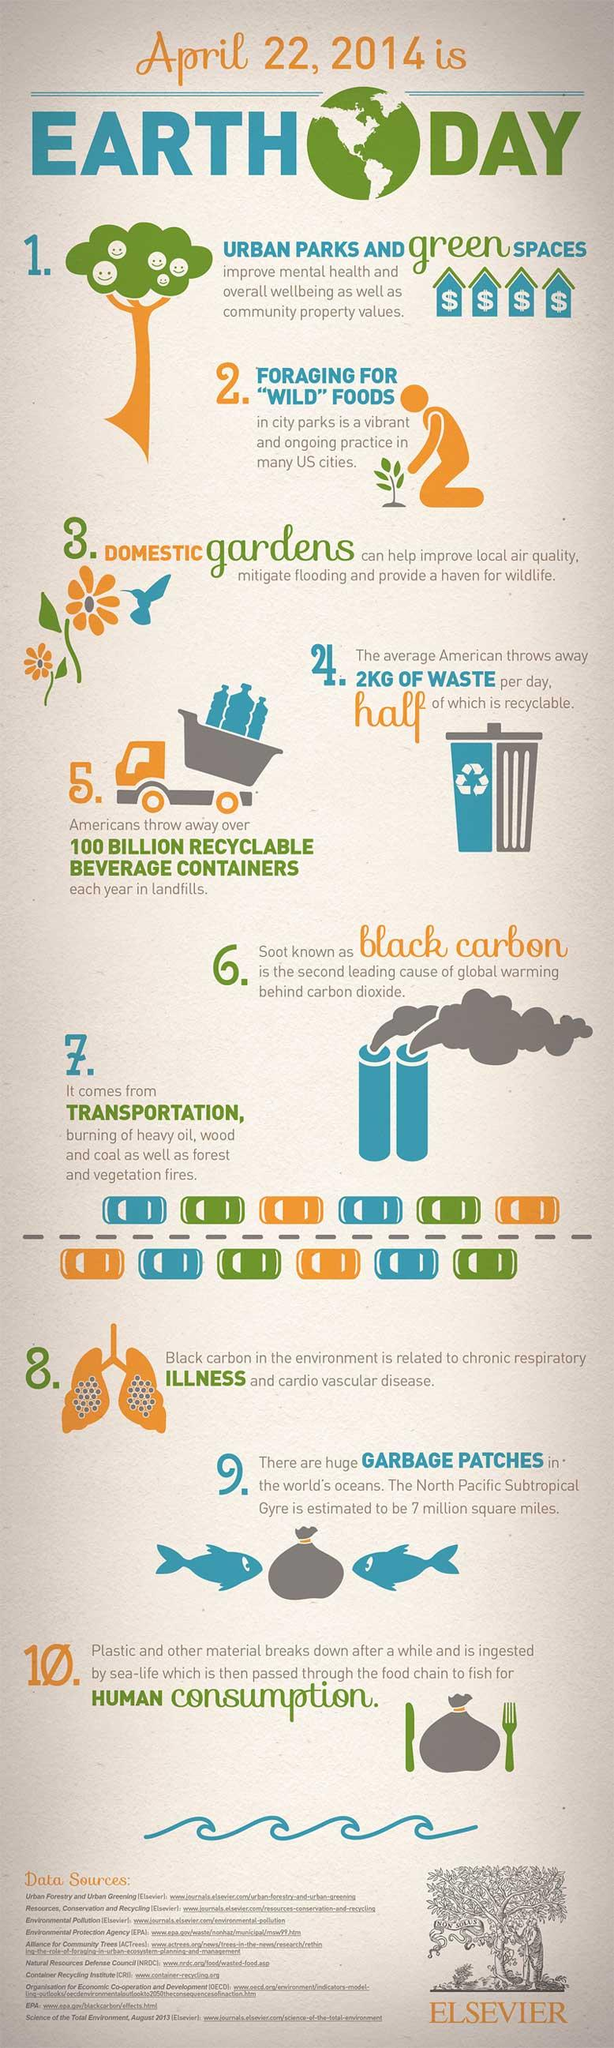Identify some key points in this picture. There is a list of 10 sources provided at the bottom. 